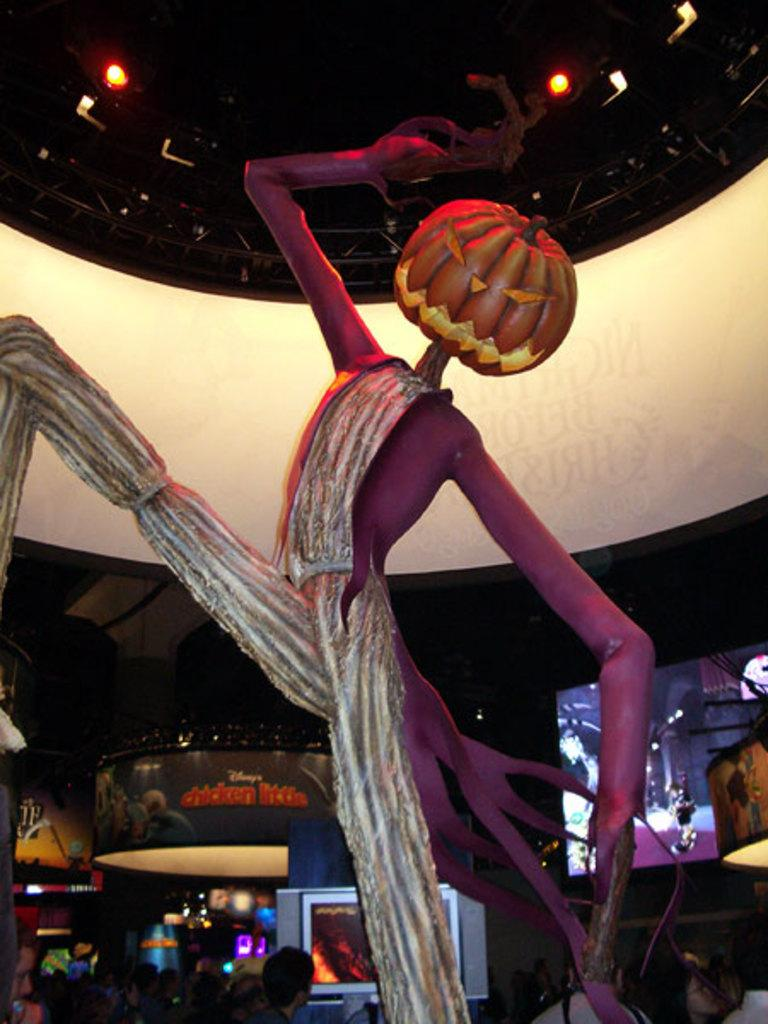What is the main subject in the center of the image? There is a statue in the center of the image. What can be seen in the background of the image? There are screens, boards, and people visible in the background of the image. What type of lighting is present in the image? There are lights visible at the top of the image. What is the structure above the statue? There is a roof in the image. What class is being taught in the image? There is no class being taught in the image; it features a statue with a roof and background elements. What record is being broken in the image? There is no record being broken in the image; it features a statue with a roof and background elements. 